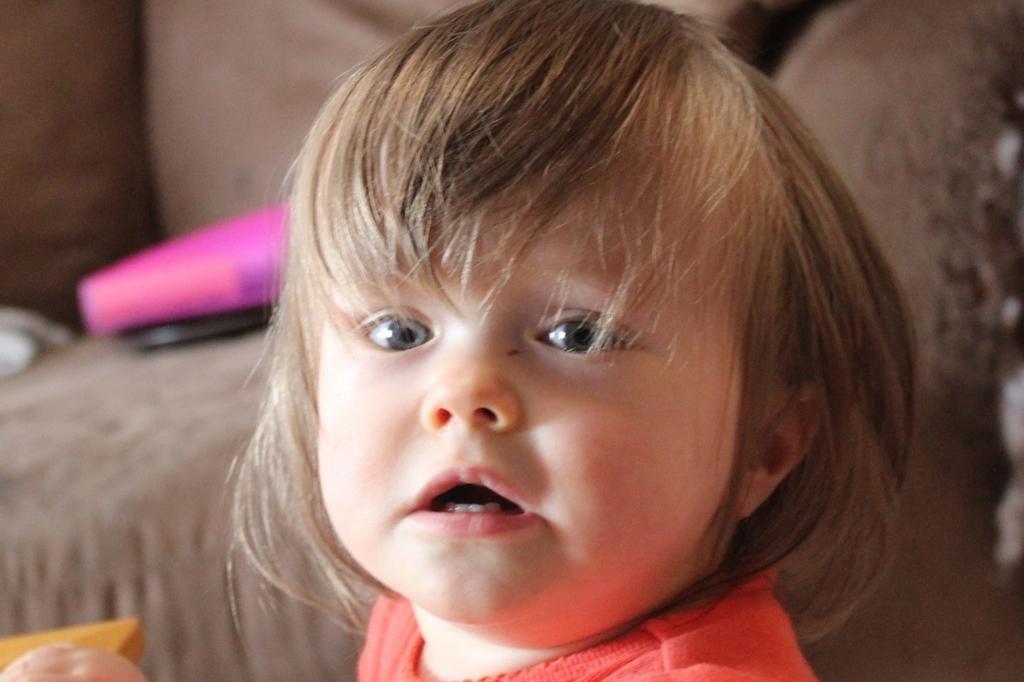In one or two sentences, can you explain what this image depicts? In this image, we can see a kid is watching. Background there is a blur view. Here we can see few objects. 